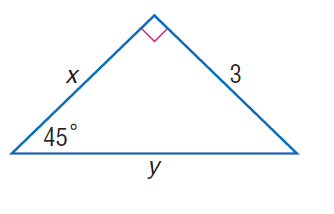Answer the mathemtical geometry problem and directly provide the correct option letter.
Question: Find x.
Choices: A: 3 B: 3 \sqrt { 2 } C: 6 D: 6 \sqrt { 2 } A 